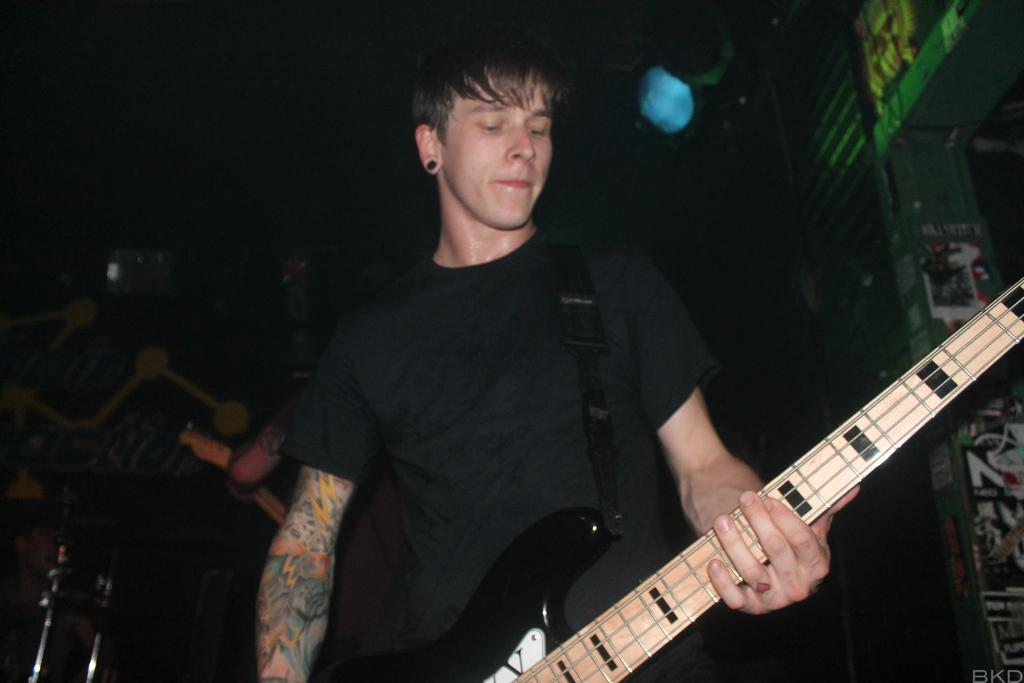Who is the main subject in the image? There is a man in the image. What is the man holding in the image? The man is holding a guitar. How is the man holding the guitar? The man is using his hand to hold the guitar. What type of chain can be seen around the sheep in the image? There is no sheep or chain present in the image; it features a man holding a guitar. 